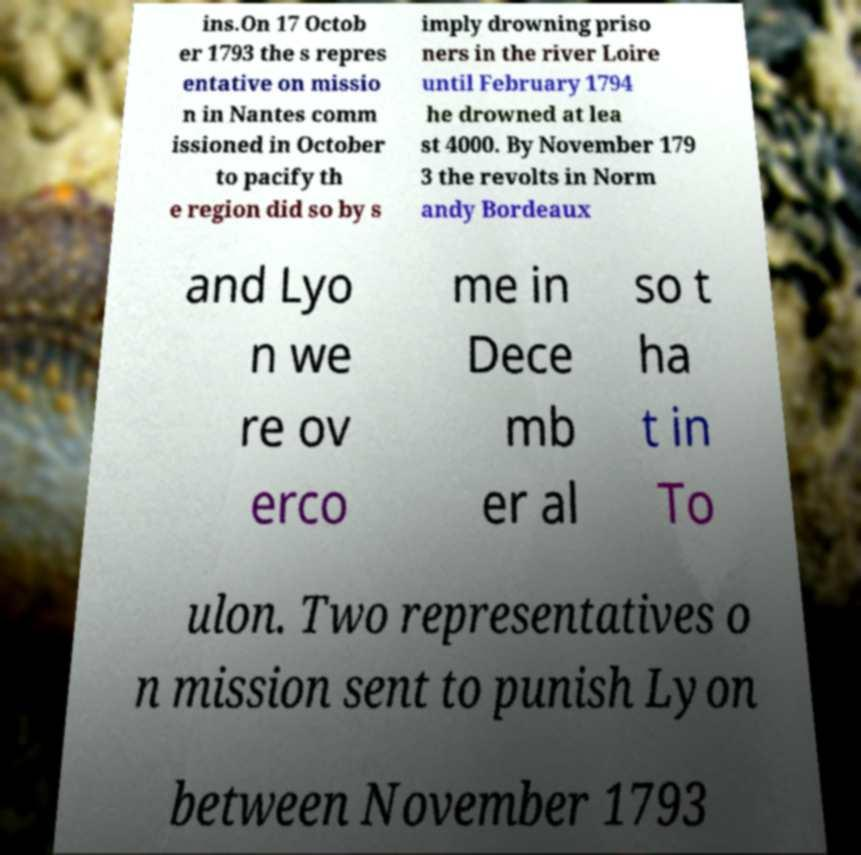Please read and relay the text visible in this image. What does it say? ins.On 17 Octob er 1793 the s repres entative on missio n in Nantes comm issioned in October to pacify th e region did so by s imply drowning priso ners in the river Loire until February 1794 he drowned at lea st 4000. By November 179 3 the revolts in Norm andy Bordeaux and Lyo n we re ov erco me in Dece mb er al so t ha t in To ulon. Two representatives o n mission sent to punish Lyon between November 1793 